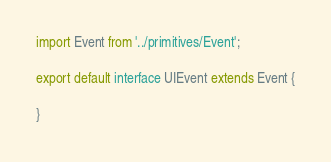Convert code to text. <code><loc_0><loc_0><loc_500><loc_500><_TypeScript_>import Event from '../primitives/Event';

export default interface UIEvent extends Event {

}
</code> 